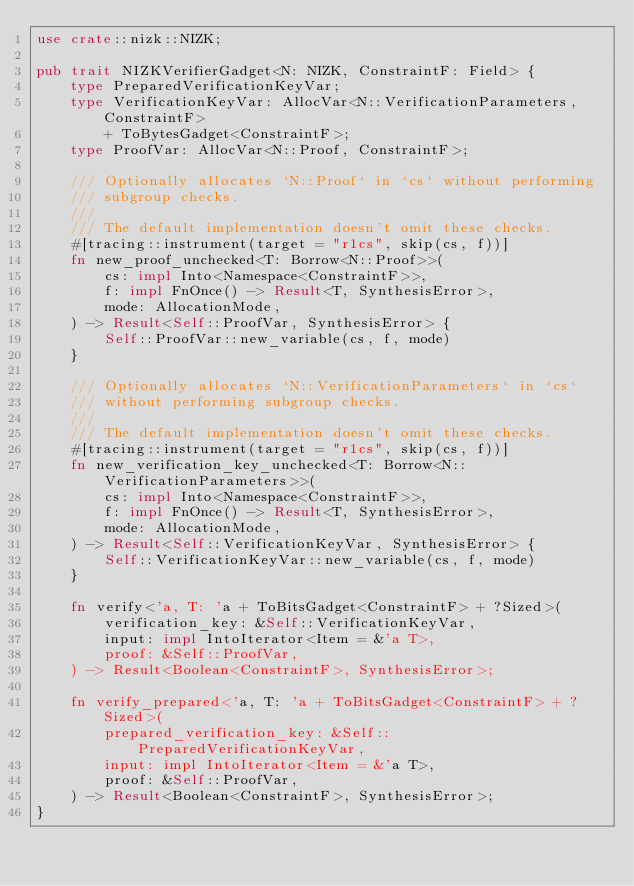Convert code to text. <code><loc_0><loc_0><loc_500><loc_500><_Rust_>use crate::nizk::NIZK;

pub trait NIZKVerifierGadget<N: NIZK, ConstraintF: Field> {
    type PreparedVerificationKeyVar;
    type VerificationKeyVar: AllocVar<N::VerificationParameters, ConstraintF>
        + ToBytesGadget<ConstraintF>;
    type ProofVar: AllocVar<N::Proof, ConstraintF>;

    /// Optionally allocates `N::Proof` in `cs` without performing
    /// subgroup checks.
    ///
    /// The default implementation doesn't omit these checks.
    #[tracing::instrument(target = "r1cs", skip(cs, f))]
    fn new_proof_unchecked<T: Borrow<N::Proof>>(
        cs: impl Into<Namespace<ConstraintF>>,
        f: impl FnOnce() -> Result<T, SynthesisError>,
        mode: AllocationMode,
    ) -> Result<Self::ProofVar, SynthesisError> {
        Self::ProofVar::new_variable(cs, f, mode)
    }

    /// Optionally allocates `N::VerificationParameters` in `cs`
    /// without performing subgroup checks.
    ///
    /// The default implementation doesn't omit these checks.
    #[tracing::instrument(target = "r1cs", skip(cs, f))]
    fn new_verification_key_unchecked<T: Borrow<N::VerificationParameters>>(
        cs: impl Into<Namespace<ConstraintF>>,
        f: impl FnOnce() -> Result<T, SynthesisError>,
        mode: AllocationMode,
    ) -> Result<Self::VerificationKeyVar, SynthesisError> {
        Self::VerificationKeyVar::new_variable(cs, f, mode)
    }

    fn verify<'a, T: 'a + ToBitsGadget<ConstraintF> + ?Sized>(
        verification_key: &Self::VerificationKeyVar,
        input: impl IntoIterator<Item = &'a T>,
        proof: &Self::ProofVar,
    ) -> Result<Boolean<ConstraintF>, SynthesisError>;

    fn verify_prepared<'a, T: 'a + ToBitsGadget<ConstraintF> + ?Sized>(
        prepared_verification_key: &Self::PreparedVerificationKeyVar,
        input: impl IntoIterator<Item = &'a T>,
        proof: &Self::ProofVar,
    ) -> Result<Boolean<ConstraintF>, SynthesisError>;
}
</code> 